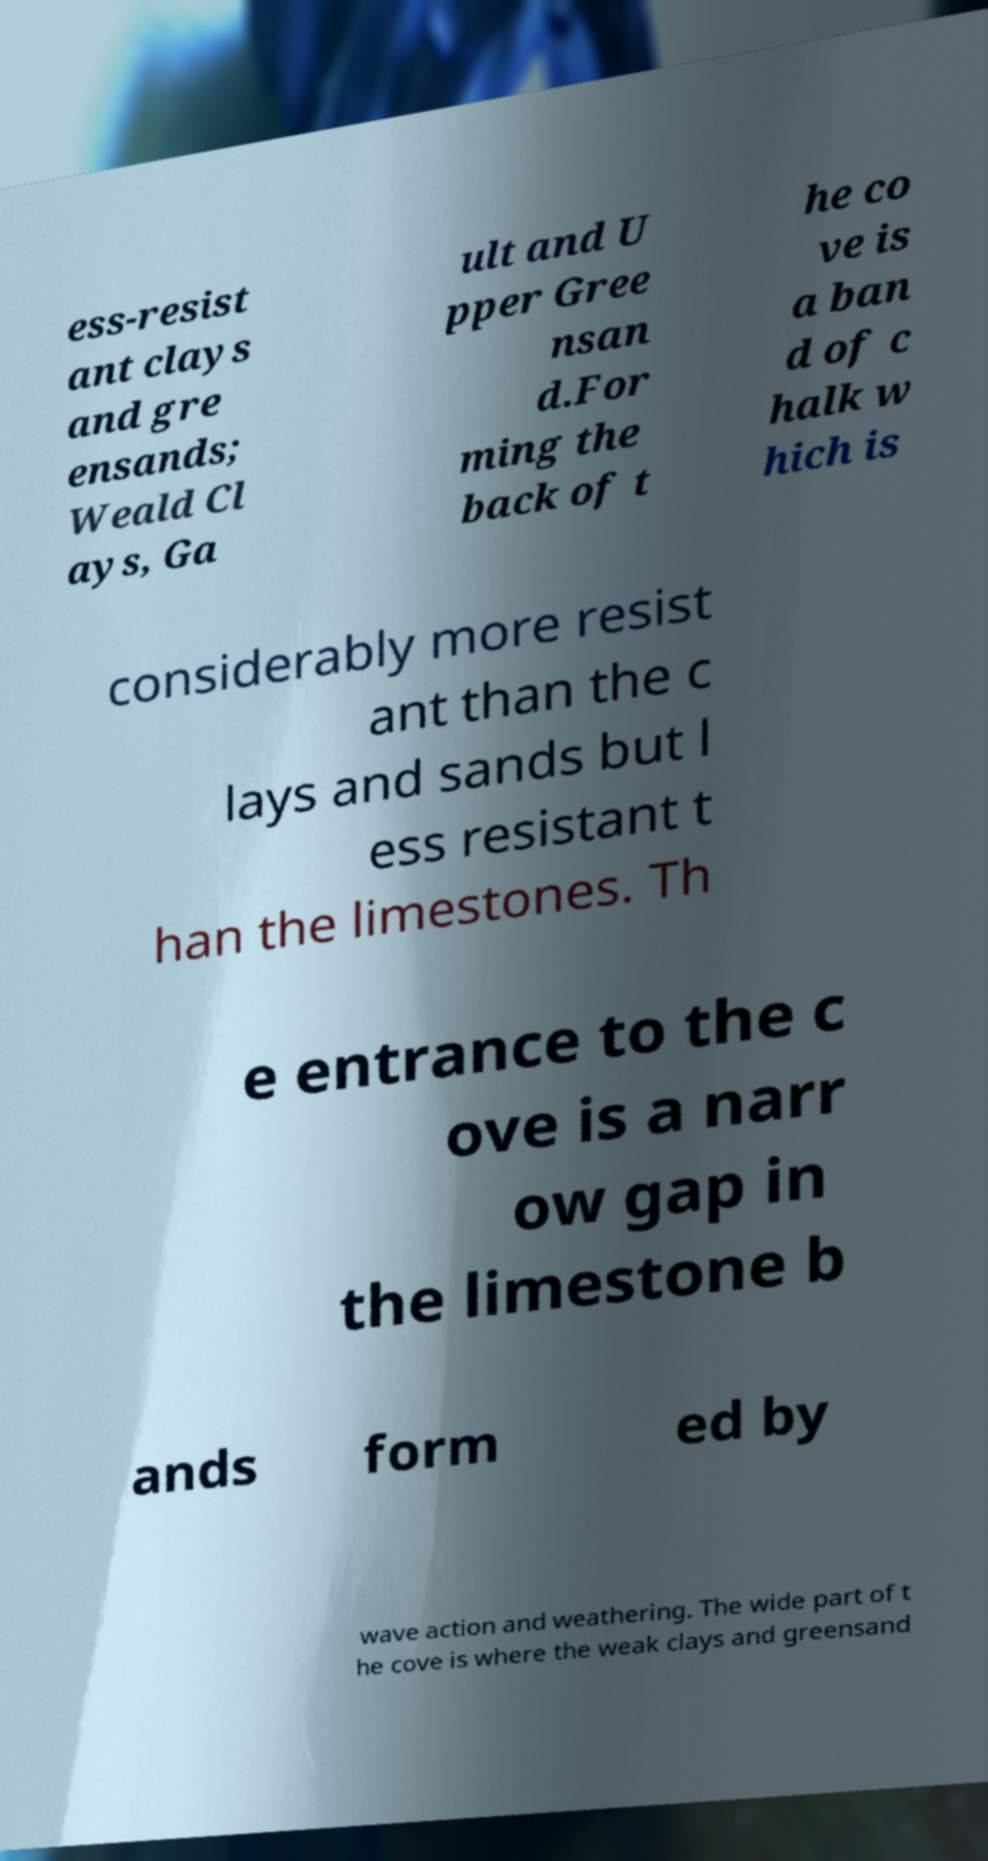There's text embedded in this image that I need extracted. Can you transcribe it verbatim? ess-resist ant clays and gre ensands; Weald Cl ays, Ga ult and U pper Gree nsan d.For ming the back of t he co ve is a ban d of c halk w hich is considerably more resist ant than the c lays and sands but l ess resistant t han the limestones. Th e entrance to the c ove is a narr ow gap in the limestone b ands form ed by wave action and weathering. The wide part of t he cove is where the weak clays and greensand 